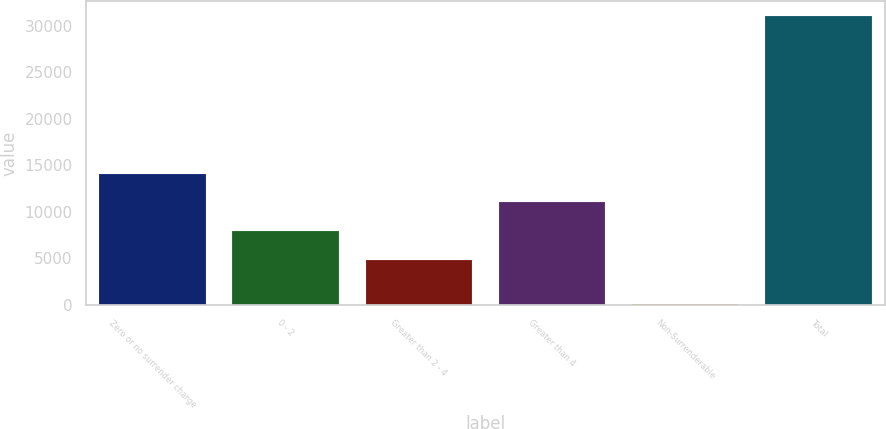<chart> <loc_0><loc_0><loc_500><loc_500><bar_chart><fcel>Zero or no surrender charge<fcel>0 - 2<fcel>Greater than 2 - 4<fcel>Greater than 4<fcel>Non-Surrenderable<fcel>Total<nl><fcel>14130.6<fcel>7930.2<fcel>4830<fcel>11030.4<fcel>91<fcel>31093<nl></chart> 